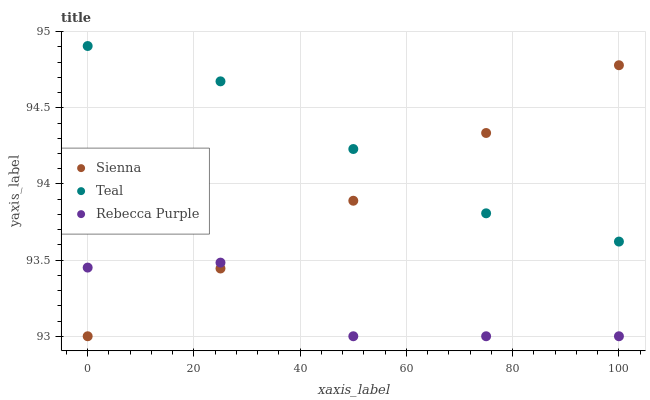Does Rebecca Purple have the minimum area under the curve?
Answer yes or no. Yes. Does Teal have the maximum area under the curve?
Answer yes or no. Yes. Does Teal have the minimum area under the curve?
Answer yes or no. No. Does Rebecca Purple have the maximum area under the curve?
Answer yes or no. No. Is Sienna the smoothest?
Answer yes or no. Yes. Is Rebecca Purple the roughest?
Answer yes or no. Yes. Is Teal the smoothest?
Answer yes or no. No. Is Teal the roughest?
Answer yes or no. No. Does Sienna have the lowest value?
Answer yes or no. Yes. Does Teal have the lowest value?
Answer yes or no. No. Does Teal have the highest value?
Answer yes or no. Yes. Does Rebecca Purple have the highest value?
Answer yes or no. No. Is Rebecca Purple less than Teal?
Answer yes or no. Yes. Is Teal greater than Rebecca Purple?
Answer yes or no. Yes. Does Teal intersect Sienna?
Answer yes or no. Yes. Is Teal less than Sienna?
Answer yes or no. No. Is Teal greater than Sienna?
Answer yes or no. No. Does Rebecca Purple intersect Teal?
Answer yes or no. No. 